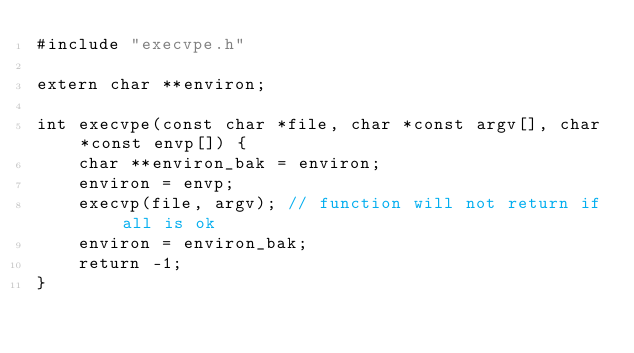<code> <loc_0><loc_0><loc_500><loc_500><_C_>#include "execvpe.h"

extern char **environ;

int execvpe(const char *file, char *const argv[], char *const envp[]) {
    char **environ_bak = environ;
    environ = envp;
    execvp(file, argv); // function will not return if all is ok
    environ = environ_bak;
    return -1;
}</code> 